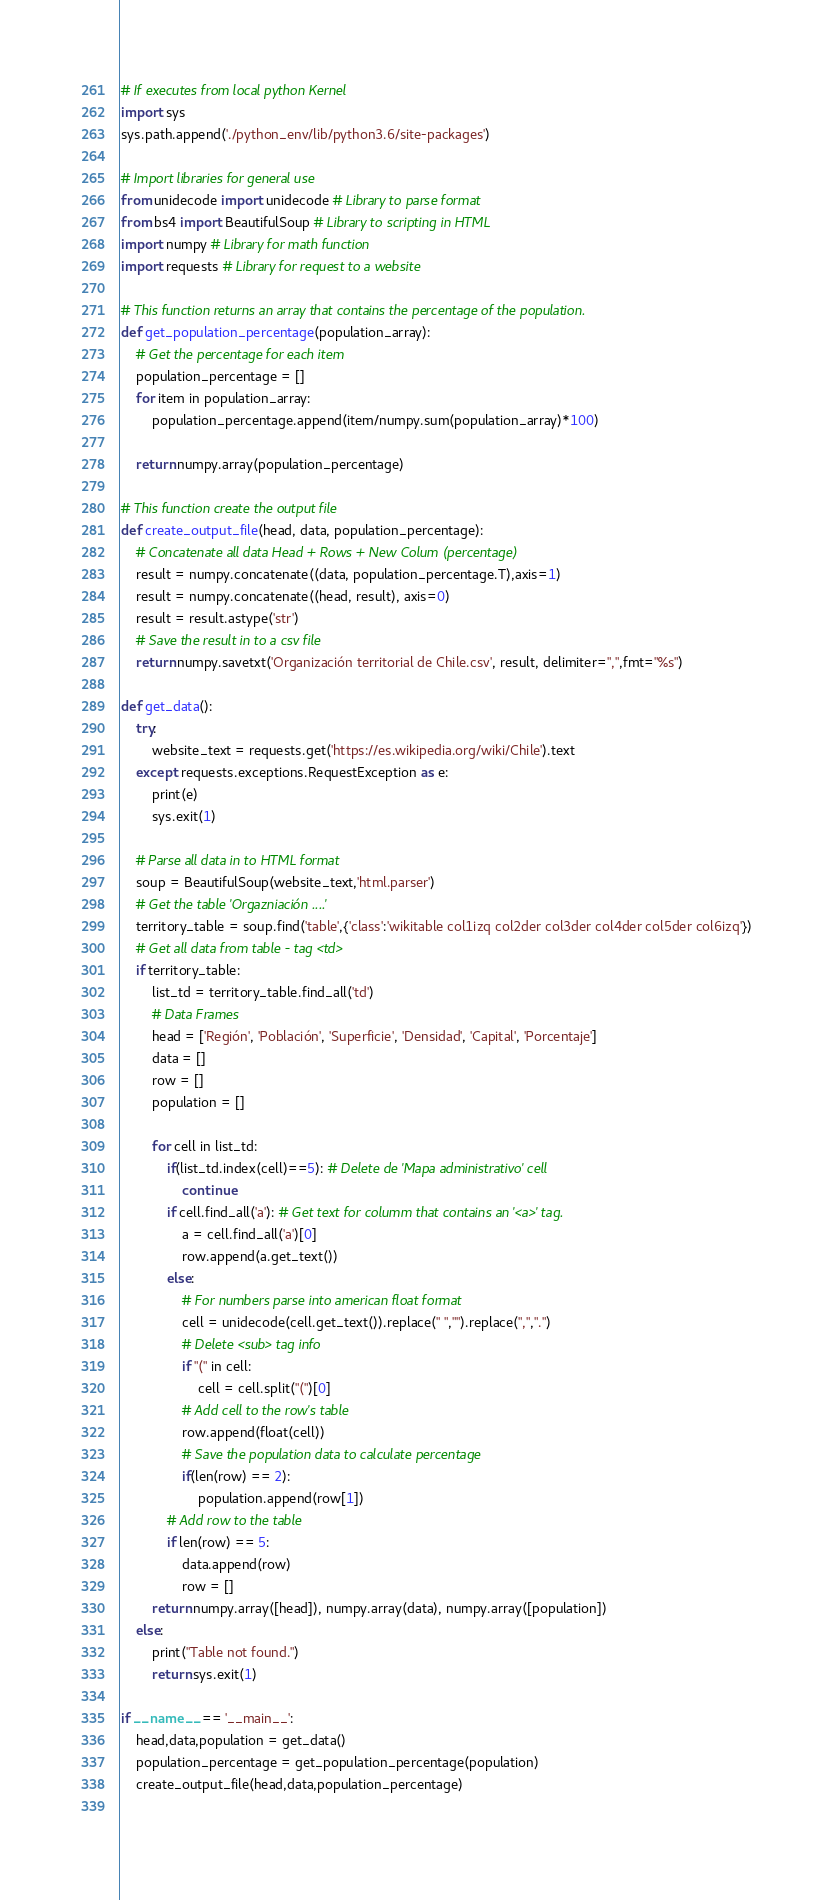<code> <loc_0><loc_0><loc_500><loc_500><_Python_># If executes from local python Kernel
import sys
sys.path.append('./python_env/lib/python3.6/site-packages')

# Import libraries for general use
from unidecode import unidecode # Library to parse format
from bs4 import BeautifulSoup # Library to scripting in HTML
import numpy # Library for math function
import requests # Library for request to a website

# This function returns an array that contains the percentage of the population.
def get_population_percentage(population_array):
    # Get the percentage for each item
    population_percentage = []
    for item in population_array:
        population_percentage.append(item/numpy.sum(population_array)*100)
    
    return numpy.array(population_percentage)

# This function create the output file
def create_output_file(head, data, population_percentage):
    # Concatenate all data Head + Rows + New Colum (percentage)
    result = numpy.concatenate((data, population_percentage.T),axis=1)
    result = numpy.concatenate((head, result), axis=0)
    result = result.astype('str')
    # Save the result in to a csv file 
    return numpy.savetxt('Organización territorial de Chile.csv', result, delimiter=",",fmt="%s")

def get_data():
    try:
        website_text = requests.get('https://es.wikipedia.org/wiki/Chile').text
    except requests.exceptions.RequestException as e:
        print(e)
        sys.exit(1)
    
    # Parse all data in to HTML format
    soup = BeautifulSoup(website_text,'html.parser')
    # Get the table 'Orgazniación ....'
    territory_table = soup.find('table',{'class':'wikitable col1izq col2der col3der col4der col5der col6izq'})
    # Get all data from table - tag <td>
    if territory_table:
        list_td = territory_table.find_all('td')
        # Data Frames
        head = ['Región', 'Población', 'Superficie', 'Densidad', 'Capital', 'Porcentaje']
        data = []
        row = []
        population = []

        for cell in list_td:
            if(list_td.index(cell)==5): # Delete de 'Mapa administrativo' cell
                continue
            if cell.find_all('a'): # Get text for columm that contains an '<a>' tag.
                a = cell.find_all('a')[0]
                row.append(a.get_text())
            else:
                # For numbers parse into american float format
                cell = unidecode(cell.get_text()).replace(" ","").replace(",",".")
                # Delete <sub> tag info
                if "(" in cell:
                    cell = cell.split("(")[0]
                # Add cell to the row's table
                row.append(float(cell))
                # Save the population data to calculate percentage
                if(len(row) == 2):
                    population.append(row[1])
            # Add row to the table
            if len(row) == 5:
                data.append(row)
                row = []  
        return numpy.array([head]), numpy.array(data), numpy.array([population])
    else:
        print("Table not found.")
        return sys.exit(1)

if __name__ == '__main__':
    head,data,population = get_data()
    population_percentage = get_population_percentage(population)
    create_output_file(head,data,population_percentage)
    </code> 